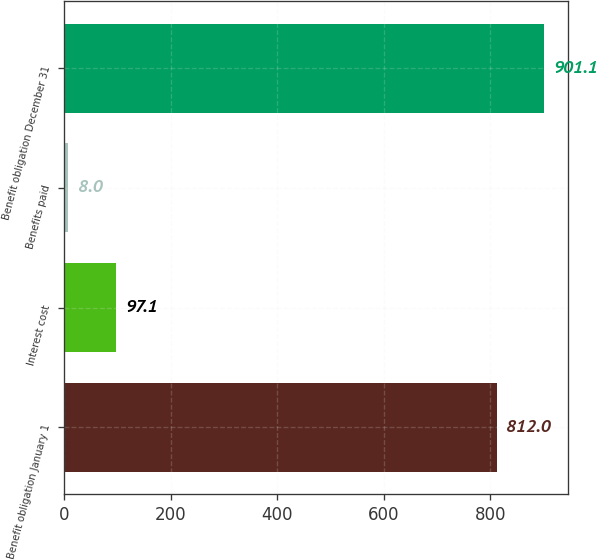Convert chart to OTSL. <chart><loc_0><loc_0><loc_500><loc_500><bar_chart><fcel>Benefit obligation January 1<fcel>Interest cost<fcel>Benefits paid<fcel>Benefit obligation December 31<nl><fcel>812<fcel>97.1<fcel>8<fcel>901.1<nl></chart> 